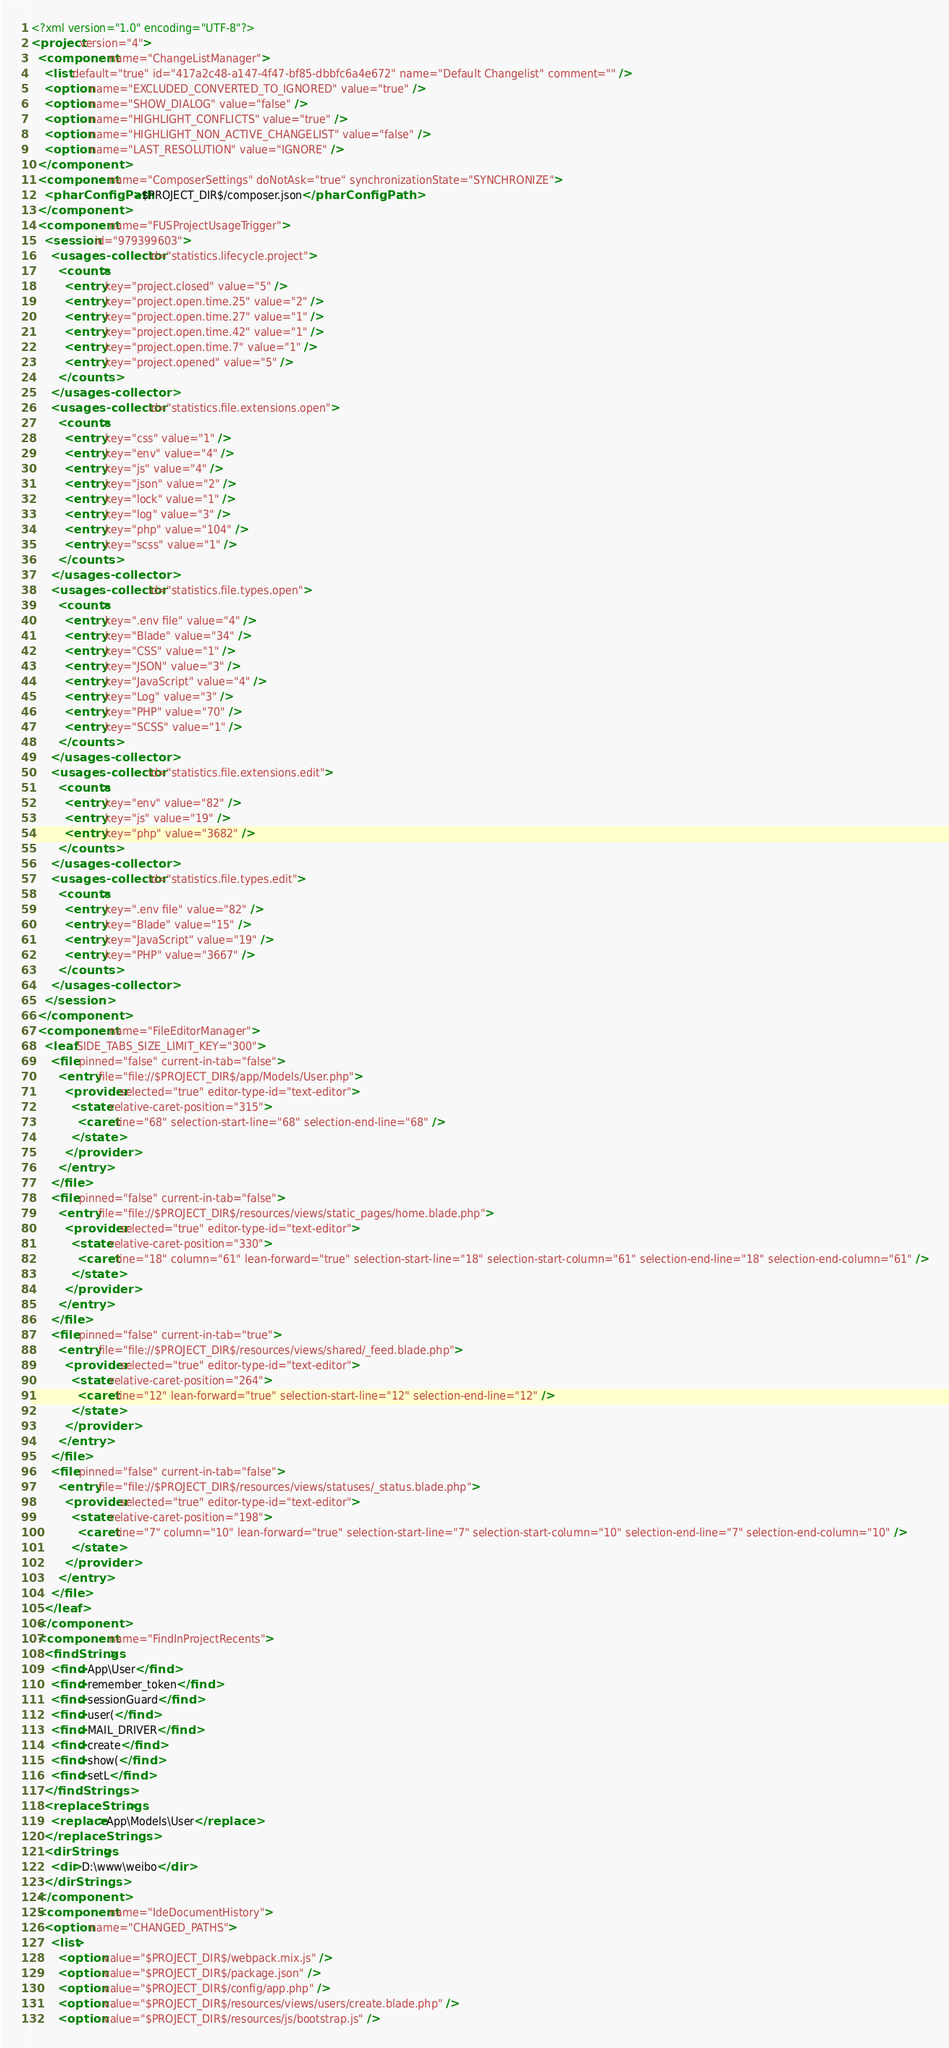Convert code to text. <code><loc_0><loc_0><loc_500><loc_500><_XML_><?xml version="1.0" encoding="UTF-8"?>
<project version="4">
  <component name="ChangeListManager">
    <list default="true" id="417a2c48-a147-4f47-bf85-dbbfc6a4e672" name="Default Changelist" comment="" />
    <option name="EXCLUDED_CONVERTED_TO_IGNORED" value="true" />
    <option name="SHOW_DIALOG" value="false" />
    <option name="HIGHLIGHT_CONFLICTS" value="true" />
    <option name="HIGHLIGHT_NON_ACTIVE_CHANGELIST" value="false" />
    <option name="LAST_RESOLUTION" value="IGNORE" />
  </component>
  <component name="ComposerSettings" doNotAsk="true" synchronizationState="SYNCHRONIZE">
    <pharConfigPath>$PROJECT_DIR$/composer.json</pharConfigPath>
  </component>
  <component name="FUSProjectUsageTrigger">
    <session id="979399603">
      <usages-collector id="statistics.lifecycle.project">
        <counts>
          <entry key="project.closed" value="5" />
          <entry key="project.open.time.25" value="2" />
          <entry key="project.open.time.27" value="1" />
          <entry key="project.open.time.42" value="1" />
          <entry key="project.open.time.7" value="1" />
          <entry key="project.opened" value="5" />
        </counts>
      </usages-collector>
      <usages-collector id="statistics.file.extensions.open">
        <counts>
          <entry key="css" value="1" />
          <entry key="env" value="4" />
          <entry key="js" value="4" />
          <entry key="json" value="2" />
          <entry key="lock" value="1" />
          <entry key="log" value="3" />
          <entry key="php" value="104" />
          <entry key="scss" value="1" />
        </counts>
      </usages-collector>
      <usages-collector id="statistics.file.types.open">
        <counts>
          <entry key=".env file" value="4" />
          <entry key="Blade" value="34" />
          <entry key="CSS" value="1" />
          <entry key="JSON" value="3" />
          <entry key="JavaScript" value="4" />
          <entry key="Log" value="3" />
          <entry key="PHP" value="70" />
          <entry key="SCSS" value="1" />
        </counts>
      </usages-collector>
      <usages-collector id="statistics.file.extensions.edit">
        <counts>
          <entry key="env" value="82" />
          <entry key="js" value="19" />
          <entry key="php" value="3682" />
        </counts>
      </usages-collector>
      <usages-collector id="statistics.file.types.edit">
        <counts>
          <entry key=".env file" value="82" />
          <entry key="Blade" value="15" />
          <entry key="JavaScript" value="19" />
          <entry key="PHP" value="3667" />
        </counts>
      </usages-collector>
    </session>
  </component>
  <component name="FileEditorManager">
    <leaf SIDE_TABS_SIZE_LIMIT_KEY="300">
      <file pinned="false" current-in-tab="false">
        <entry file="file://$PROJECT_DIR$/app/Models/User.php">
          <provider selected="true" editor-type-id="text-editor">
            <state relative-caret-position="315">
              <caret line="68" selection-start-line="68" selection-end-line="68" />
            </state>
          </provider>
        </entry>
      </file>
      <file pinned="false" current-in-tab="false">
        <entry file="file://$PROJECT_DIR$/resources/views/static_pages/home.blade.php">
          <provider selected="true" editor-type-id="text-editor">
            <state relative-caret-position="330">
              <caret line="18" column="61" lean-forward="true" selection-start-line="18" selection-start-column="61" selection-end-line="18" selection-end-column="61" />
            </state>
          </provider>
        </entry>
      </file>
      <file pinned="false" current-in-tab="true">
        <entry file="file://$PROJECT_DIR$/resources/views/shared/_feed.blade.php">
          <provider selected="true" editor-type-id="text-editor">
            <state relative-caret-position="264">
              <caret line="12" lean-forward="true" selection-start-line="12" selection-end-line="12" />
            </state>
          </provider>
        </entry>
      </file>
      <file pinned="false" current-in-tab="false">
        <entry file="file://$PROJECT_DIR$/resources/views/statuses/_status.blade.php">
          <provider selected="true" editor-type-id="text-editor">
            <state relative-caret-position="198">
              <caret line="7" column="10" lean-forward="true" selection-start-line="7" selection-start-column="10" selection-end-line="7" selection-end-column="10" />
            </state>
          </provider>
        </entry>
      </file>
    </leaf>
  </component>
  <component name="FindInProjectRecents">
    <findStrings>
      <find>App\User</find>
      <find>remember_token</find>
      <find>sessionGuard</find>
      <find>user(</find>
      <find>MAIL_DRIVER</find>
      <find>create</find>
      <find>show(</find>
      <find>setL</find>
    </findStrings>
    <replaceStrings>
      <replace>App\Models\User</replace>
    </replaceStrings>
    <dirStrings>
      <dir>D:\www\weibo</dir>
    </dirStrings>
  </component>
  <component name="IdeDocumentHistory">
    <option name="CHANGED_PATHS">
      <list>
        <option value="$PROJECT_DIR$/webpack.mix.js" />
        <option value="$PROJECT_DIR$/package.json" />
        <option value="$PROJECT_DIR$/config/app.php" />
        <option value="$PROJECT_DIR$/resources/views/users/create.blade.php" />
        <option value="$PROJECT_DIR$/resources/js/bootstrap.js" /></code> 